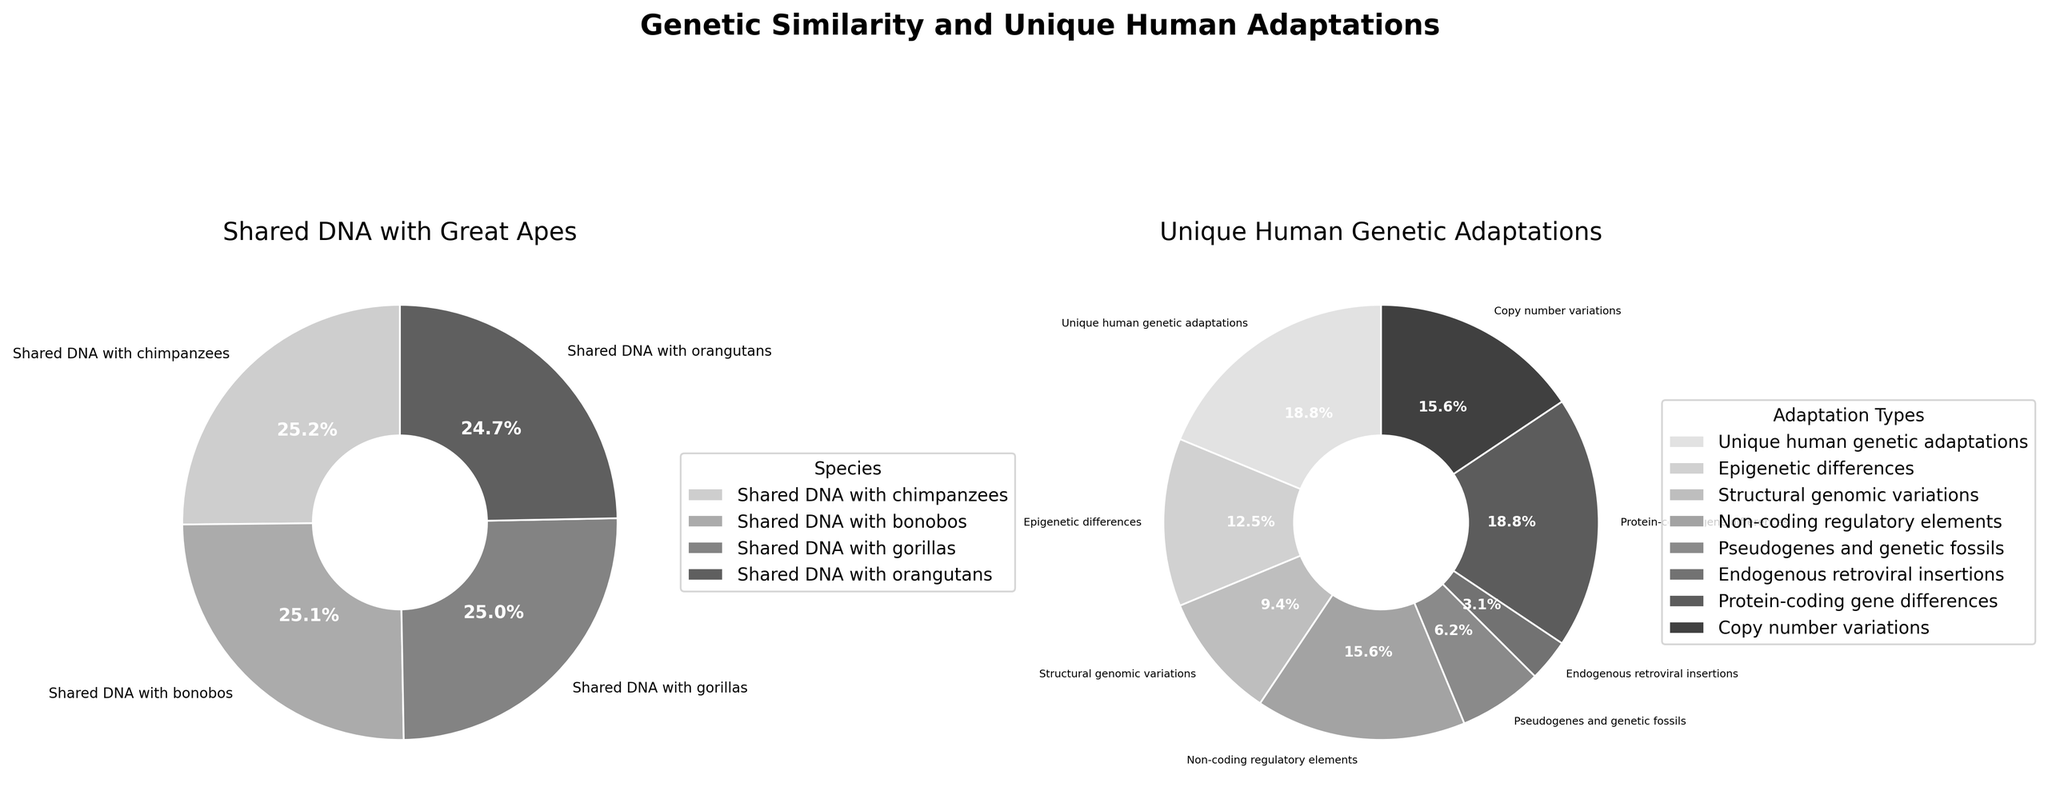What's the total percentage of shared DNA with great apes? To find the total percentage, sum the percentages of shared DNA with chimpanzees (98.8), bonobos (98.7), gorillas (98.3), and orangutans (97.0). So, the total is 98.8 + 98.7 + 98.3 + 97.0 = 392.8
Answer: 392.8% Which great ape has the highest genetic similarity to humans? Comparing the percentages of shared DNA, chimpanzees have the highest genetic similarity at 98.8%, which is higher than bonobos (98.7%), gorillas (98.3%), and orangutans (97.0%).
Answer: Chimpanzees Which category of unique adaptations has the highest percentage? By examining the unique human genetic adaptations pie chart, the category with the highest percentage is "Unique human genetic adaptations" at 0.6%.
Answer: Unique human genetic adaptations What's the percentage difference between the highest and lowest shared DNA categories? The highest is shared DNA with chimpanzees (98.8%), and the lowest is shared DNA with orangutans (97.0%). The difference is 98.8 - 97.0 = 1.8%.
Answer: 1.8% What's the combined percentage of all unique human adaptations? Sum the percentages of unique human genetic adaptations (0.6), epigenetic differences (0.4), structural genomic variations (0.3), non-coding regulatory elements (0.5), pseudogenes and genetic fossils (0.2), endogenous retroviral insertions (0.1), protein-coding gene differences (0.6), and copy number variations (0.5). So, the total is 0.6 + 0.4 + 0.3 + 0.5 + 0.2 + 0.1 + 0.6 + 0.5 = 3.2%.
Answer: 3.2% Which is greater: the percentage of epigenetic differences or non-coding regulatory elements? The percentage of non-coding regulatory elements (0.5%) is greater than epigenetic differences (0.4%).
Answer: Non-coding regulatory elements What's the percentage difference between protein-coding gene differences and endogenous retroviral insertions? The percentage for protein-coding gene differences is 0.6%, and for endogenous retroviral insertions, it's 0.1%. The difference is 0.6 - 0.1 = 0.5%.
Answer: 0.5% Which part of the chart uses darker shades of gray? Visual attributes indicate that the main pie chart (Shared DNA with Great Apes) uses darker shades of gray compared to the sub-categories.
Answer: Main pie chart Considering the percentages of copy number variations and unique human genetic adaptations, which is higher, and by how much? Unique human genetic adaptations (0.6%) are higher than copy number variations (0.5%). The difference is 0.6 - 0.5 = 0.1%.
Answer: Unique human genetic adaptations by 0.1% What's the median percentage of the main categories in the shared DNA chart? Main categories: 98.8, 98.7, 98.3, 97.0. Sorting: 97.0, 98.3, 98.7, 98.8. The median is the average of the two middle numbers: (98.3 + 98.7)/2 = 98.5.
Answer: 98.5% 